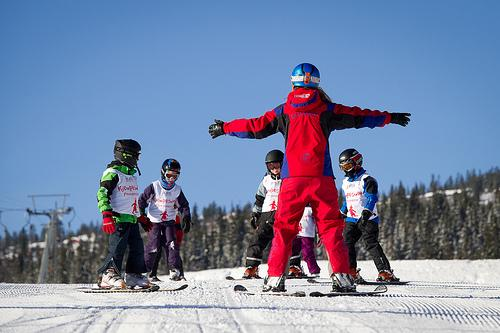What is the state of the photo in the ad according to the text? The photo is no longer available as per the text in the ad. What is the main message conveyed by the ad? The main message is that the photo in the frame is no longer available, and the ad has a white background with grey text. What is the color of the print and the sign in the image? Both the print and the sign are grey in color. What is the color and description of the background in the image? The background is blank and white in color, covering a large chunk of the image. Explain the content of the sentence in the image. The sentence says "photo is no longer available," indicating the absence of a photo in the frame. 